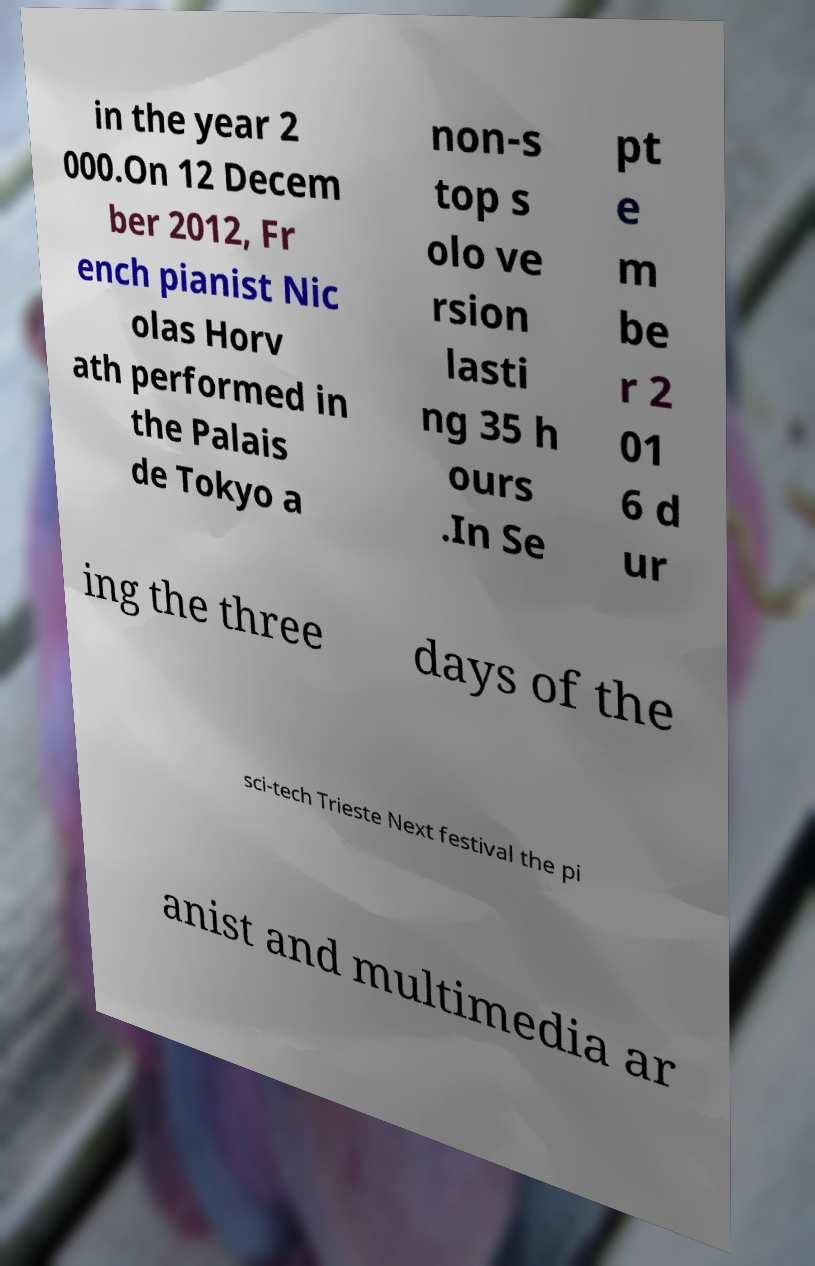I need the written content from this picture converted into text. Can you do that? in the year 2 000.On 12 Decem ber 2012, Fr ench pianist Nic olas Horv ath performed in the Palais de Tokyo a non-s top s olo ve rsion lasti ng 35 h ours .In Se pt e m be r 2 01 6 d ur ing the three days of the sci-tech Trieste Next festival the pi anist and multimedia ar 